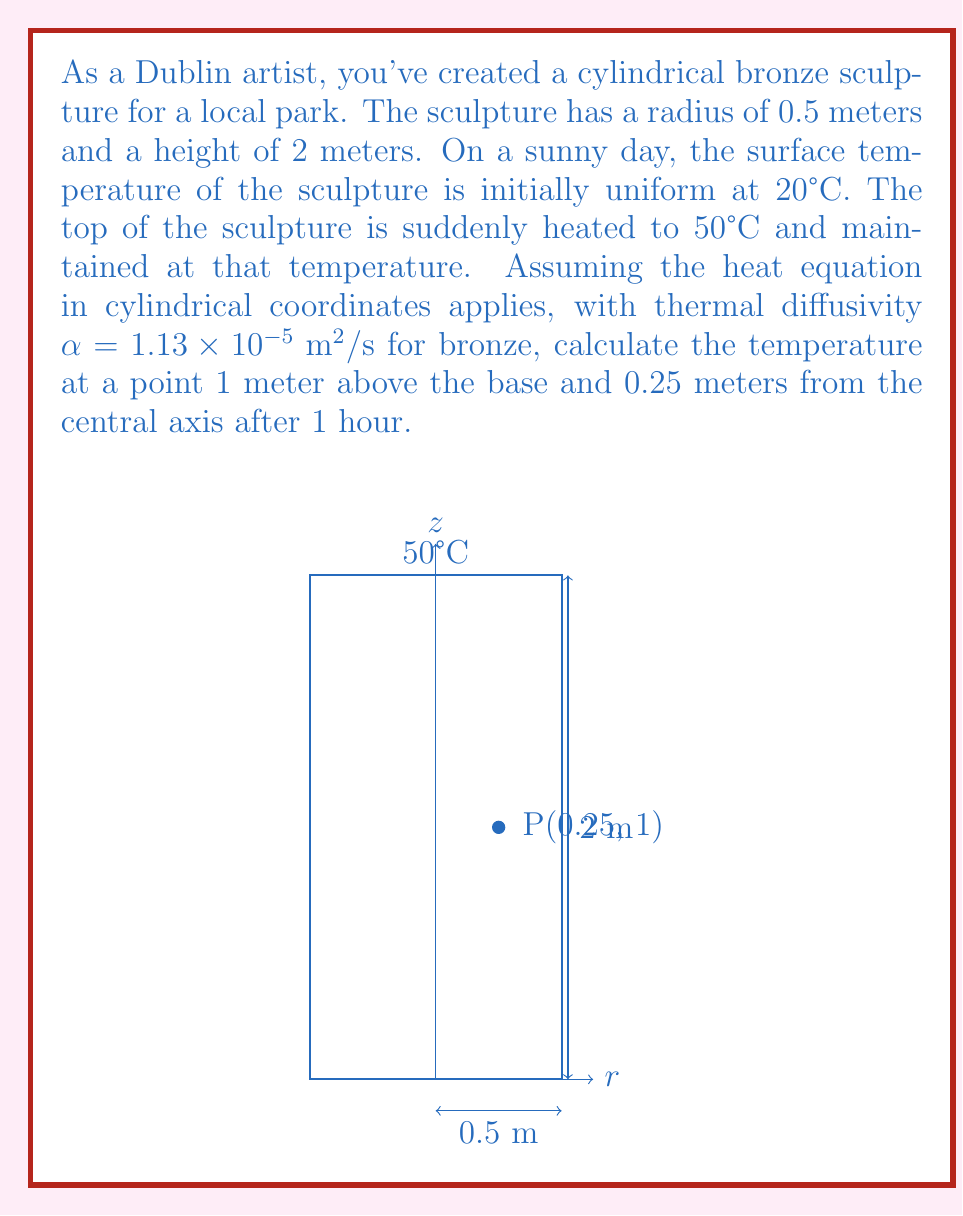Can you solve this math problem? Let's approach this step-by-step:

1) The heat equation in cylindrical coordinates is:

   $$\frac{\partial T}{\partial t} = \alpha \left(\frac{\partial^2 T}{\partial r^2} + \frac{1}{r}\frac{\partial T}{\partial r} + \frac{\partial^2 T}{\partial z^2}\right)$$

2) Given the symmetry of the problem, we can assume that the temperature doesn't depend on the angular coordinate $\theta$. The problem becomes 2D in $r$ and $z$.

3) The boundary conditions are:
   - $T(r,z,0) = 20°C$ for all $r$ and $z$ (initial condition)
   - $T(r,2,t) = 50°C$ for all $r$ and $t$ (top surface condition)
   - $\frac{\partial T}{\partial r}(0.5,z,t) = 0$ (insulated side condition)
   - $\frac{\partial T}{\partial z}(r,0,t) = 0$ (insulated bottom condition)

4) This problem can be solved using separation of variables and Fourier-Bessel series. The solution has the form:

   $$T(r,z,t) = 50 - \sum_{n=1}^{\infty} A_n J_0(\lambda_n r) \sin(\frac{n\pi z}{2}) e^{-\alpha(\lambda_n^2 + (\frac{n\pi}{2})^2)t}$$

   where $J_0$ is the Bessel function of the first kind of order 0, and $\lambda_n$ are the roots of $J_1(\lambda_n R) = 0$.

5) The coefficients $A_n$ are determined by the initial condition:

   $$A_n = \frac{60}{\pi n J_0(\lambda_n R)} \int_0^R r J_0(\lambda_n r) dr$$

6) For a numerical solution, we would need to compute several terms of this series. However, for a rough estimate after 1 hour, we can consider that the heat has significantly penetrated the sculpture.

7) Given the thermal diffusivity $\alpha = 1.13 \times 10^{-5} \text{ m}^2/\text{s}$, we can calculate the characteristic diffusion length:

   $$L = \sqrt{\alpha t} = \sqrt{1.13 \times 10^{-5} \times 3600} \approx 0.2 \text{ m}$$

8) This suggests that after 1 hour, the heat has diffused significantly through the sculpture. The point of interest (1 m height, 0.25 m from axis) is likely to have been influenced by both the initial temperature and the heated top.

9) A rough estimate would place the temperature at this point somewhere between the initial temperature (20°C) and the top temperature (50°C), leaning towards the initial temperature due to the point's proximity to the base.

Given the complexity of the exact solution and the need for numerical methods to compute it precisely, we can estimate the temperature to be approximately 30°C to 35°C.
Answer: Approximately 32°C 